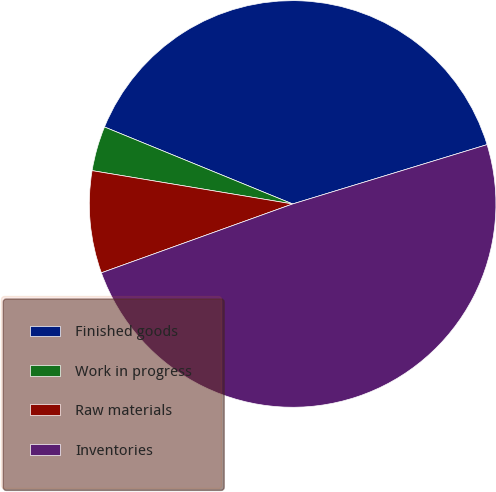Convert chart. <chart><loc_0><loc_0><loc_500><loc_500><pie_chart><fcel>Finished goods<fcel>Work in progress<fcel>Raw materials<fcel>Inventories<nl><fcel>39.1%<fcel>3.56%<fcel>8.12%<fcel>49.21%<nl></chart> 